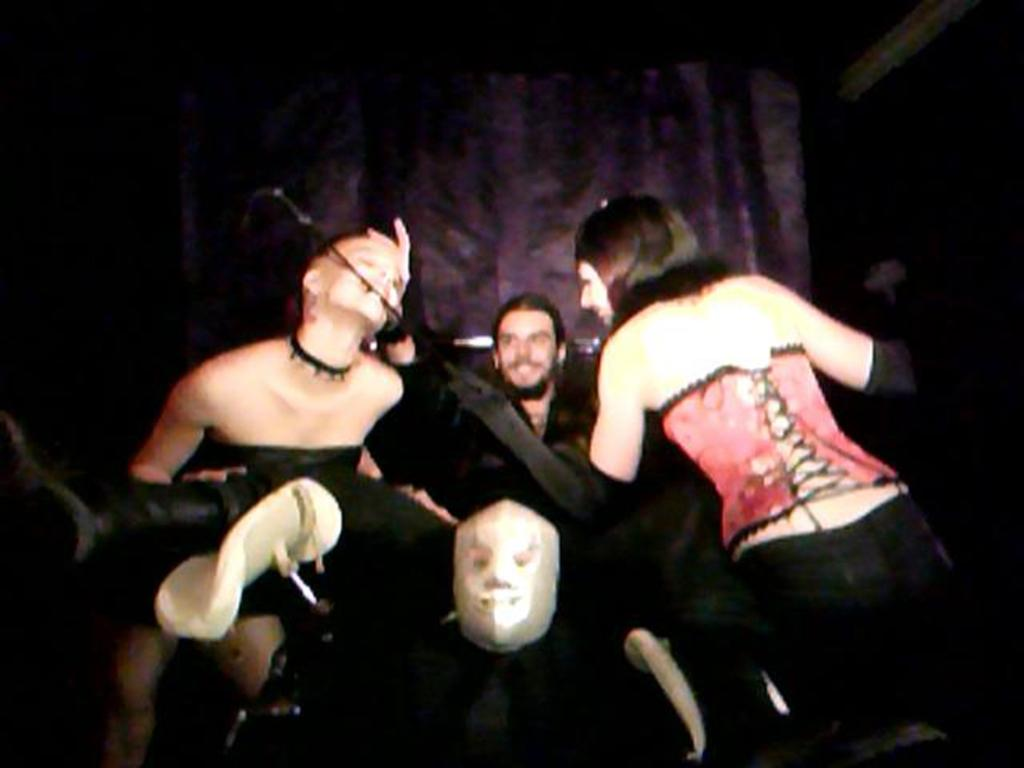How many people are in the image? The number of people in the image cannot be determined from the provided facts. What can be observed about the background of the image? The background of the image is dark. What type of bridge can be seen in the image? There is no bridge present in the image. What kind of destruction is happening in the image? There is no destruction present in the image. 